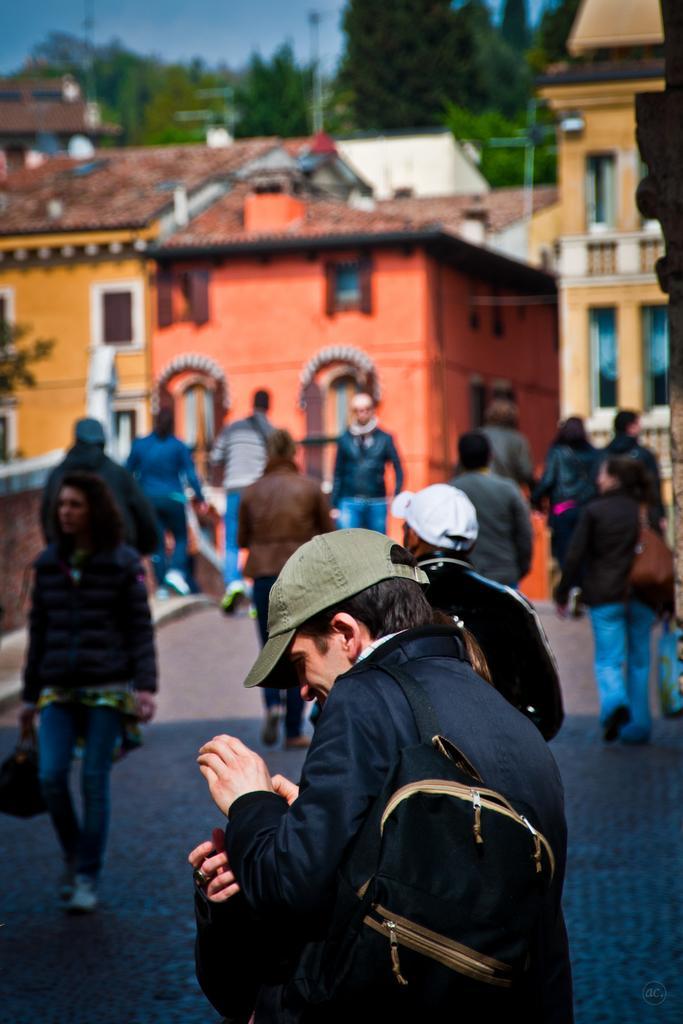Can you describe this image briefly? As we can see in the image there are few people here and there walking, buildings, trees and sky. 